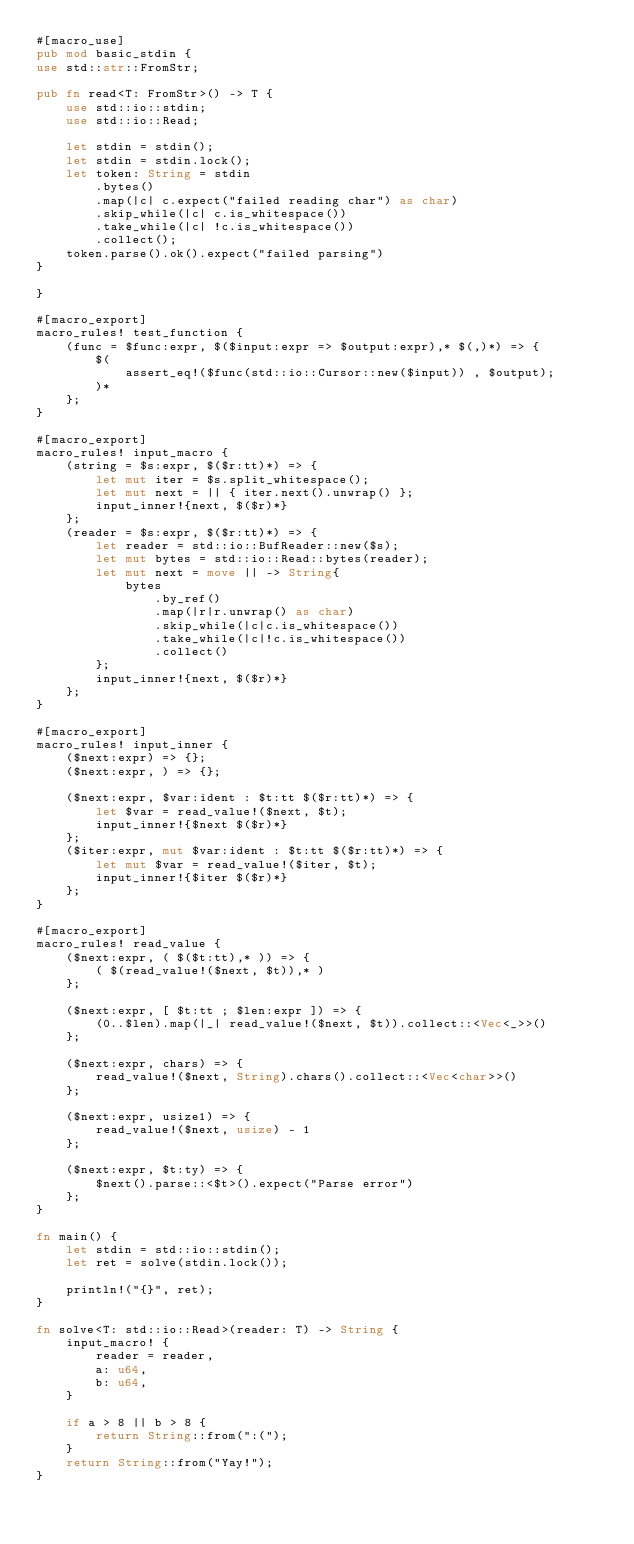Convert code to text. <code><loc_0><loc_0><loc_500><loc_500><_Rust_>#[macro_use]
pub mod basic_stdin {
use std::str::FromStr;

pub fn read<T: FromStr>() -> T {
    use std::io::stdin;
    use std::io::Read;

    let stdin = stdin();
    let stdin = stdin.lock();
    let token: String = stdin
        .bytes()
        .map(|c| c.expect("failed reading char") as char)
        .skip_while(|c| c.is_whitespace())
        .take_while(|c| !c.is_whitespace())
        .collect();
    token.parse().ok().expect("failed parsing")
}

}

#[macro_export]
macro_rules! test_function {
    (func = $func:expr, $($input:expr => $output:expr),* $(,)*) => {
        $(
            assert_eq!($func(std::io::Cursor::new($input)) , $output);
        )*
    };
}

#[macro_export]
macro_rules! input_macro {
    (string = $s:expr, $($r:tt)*) => {
        let mut iter = $s.split_whitespace();
        let mut next = || { iter.next().unwrap() };
        input_inner!{next, $($r)*}
    };
    (reader = $s:expr, $($r:tt)*) => {
        let reader = std::io::BufReader::new($s);
        let mut bytes = std::io::Read::bytes(reader);
        let mut next = move || -> String{
            bytes
                .by_ref()
                .map(|r|r.unwrap() as char)
                .skip_while(|c|c.is_whitespace())
                .take_while(|c|!c.is_whitespace())
                .collect()
        };
        input_inner!{next, $($r)*}
    };
}

#[macro_export]
macro_rules! input_inner {
    ($next:expr) => {};
    ($next:expr, ) => {};

    ($next:expr, $var:ident : $t:tt $($r:tt)*) => {
        let $var = read_value!($next, $t);
        input_inner!{$next $($r)*}
    };
    ($iter:expr, mut $var:ident : $t:tt $($r:tt)*) => {
        let mut $var = read_value!($iter, $t);
        input_inner!{$iter $($r)*}
    };
}

#[macro_export]
macro_rules! read_value {
    ($next:expr, ( $($t:tt),* )) => {
        ( $(read_value!($next, $t)),* )
    };

    ($next:expr, [ $t:tt ; $len:expr ]) => {
        (0..$len).map(|_| read_value!($next, $t)).collect::<Vec<_>>()
    };

    ($next:expr, chars) => {
        read_value!($next, String).chars().collect::<Vec<char>>()
    };

    ($next:expr, usize1) => {
        read_value!($next, usize) - 1
    };

    ($next:expr, $t:ty) => {
        $next().parse::<$t>().expect("Parse error")
    };
}

fn main() {
    let stdin = std::io::stdin();
    let ret = solve(stdin.lock());

    println!("{}", ret);
}

fn solve<T: std::io::Read>(reader: T) -> String {
    input_macro! {
        reader = reader,
        a: u64,
        b: u64,
    }

    if a > 8 || b > 8 {
        return String::from(":(");
    }
    return String::from("Yay!");
}
</code> 